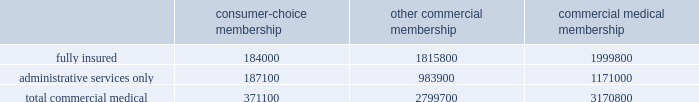Cost amount could have a material adverse effect on our business .
These changes may include , for example , an increase or reduction in the number of persons enrolled or eligible to enroll due to the federal government 2019s decision to increase or decrease u.s .
Military presence around the world .
In the event government reimbursements were to decline from projected amounts , our failure to reduce the health care costs associated with these programs could have a material adverse effect on our business .
During 2004 , we completed a contractual transition of our tricare business .
On july 1 , 2004 , our regions 2 and 5 contract servicing approximately 1.1 million tricare members became part of the new north region , which was awarded to another contractor .
On august 1 , 2004 , our regions 3 and 4 contract became part of our new south region contract .
On november 1 , 2004 , the region 6 contract with approximately 1 million members became part of the south region contract .
The members added with the region 6 contract essentially offset the members lost four months earlier with the expiration of our regions 2 and 5 contract .
For the year ended december 31 , 2005 , tricare premium revenues were approximately $ 2.4 billion , or 16.9% ( 16.9 % ) of our total premiums and aso fees .
Part of the tricare transition during 2004 included the carve out of the tricare senior pharmacy and tricare for life program which we previously administered on as aso basis .
On june 1 , 2004 and august 1 , 2004 , administrative services under these programs were transferred to another contractor .
For the year ended december 31 , 2005 , tricare administrative services fees totaled $ 50.1 million , or 0.4% ( 0.4 % ) of our total premiums and aso fees .
Our products marketed to commercial segment employers and members consumer-choice products over the last several years , we have developed and offered various commercial products designed to provide options and choices to employers that are annually facing substantial premium increases driven by double-digit medical cost inflation .
These consumer-choice products , which can be offered on either a fully insured or aso basis , provided coverage to approximately 371100 members at december 31 , 2005 , representing approximately 11.7% ( 11.7 % ) of our total commercial medical membership as detailed below .
Consumer-choice membership other commercial membership commercial medical membership .
These products are often offered to employer groups as 201cbundles 201d , where the subscribers are offered various hmo and ppo options , with various employer contribution strategies as determined by the employer .
Paramount to our consumer-choice product strategy , we have developed a group of innovative consumer products , styled as 201csmart 201d products , that we believe will be a long-term solution for employers .
We believe this new generation of products provides more ( 1 ) choices for the individual consumer , ( 2 ) transparency of provider costs , and ( 3 ) benefit designs that engage consumers in the costs and effectiveness of health care choices .
Innovative tools and technology are available to assist consumers with these decisions , including the trade-offs between higher premiums and point-of-service costs at the time consumers choose their plans , and to suggest ways in which the consumers can maximize their individual benefits at the point they use their plans .
We believe that when consumers can make informed choices about the cost and effectiveness of their health care , a sustainable long term solution for employers can be realized .
Smart products , which accounted for approximately 65.1% ( 65.1 % ) of enrollment in all of our consumer-choice plans as of december 31 , 2005 , only are sold to employers who use humana as their sole health insurance carrier. .
Considering the other commercial membership , what is the percentage of fully insured plans among the total commercial medical plans? 
Rationale: it is the number of members of the fully insured plans divided by the members of the total commercial medical plans .
Computations: (1815800 / 2799700)
Answer: 0.64857. 